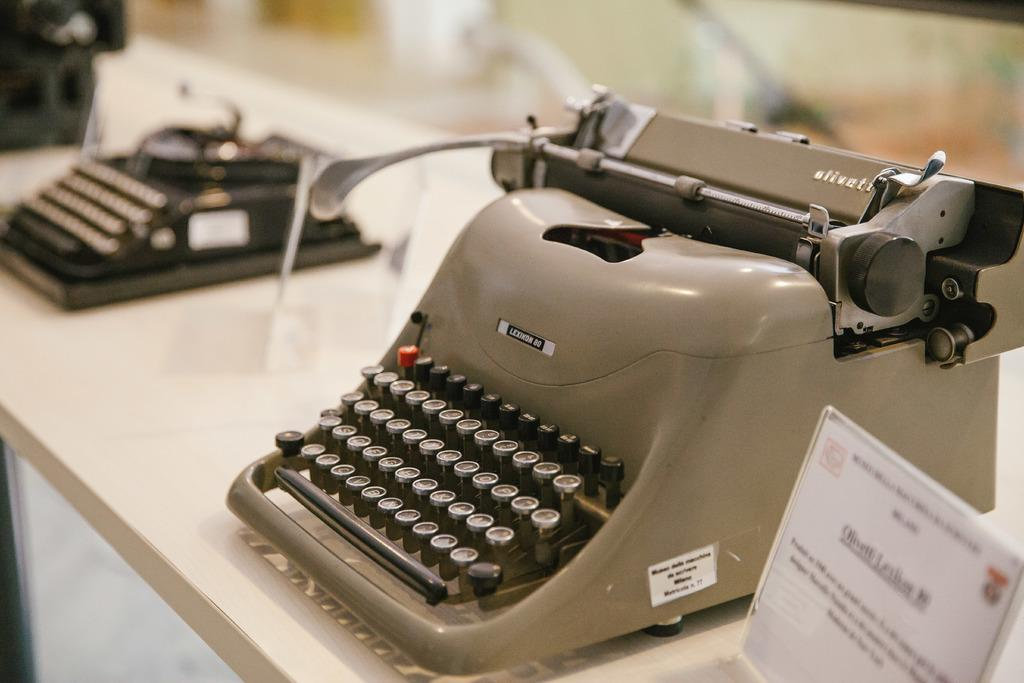<image>
Describe the image concisely. An antique Olivett typewriter, model Lexikon 80 is sitting on a table. 